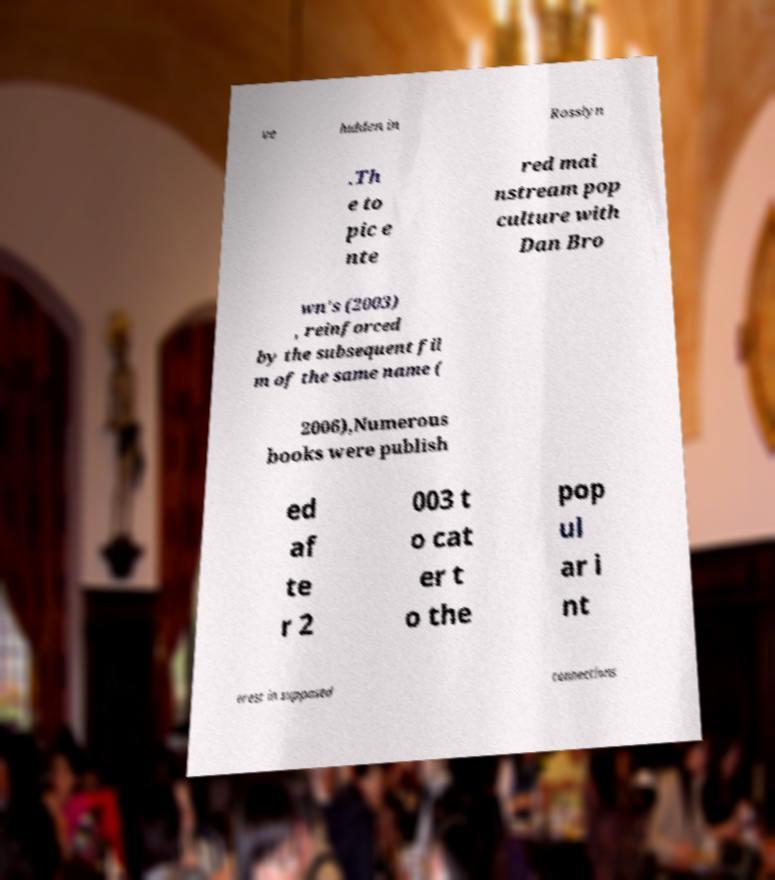I need the written content from this picture converted into text. Can you do that? ve hidden in Rosslyn .Th e to pic e nte red mai nstream pop culture with Dan Bro wn's (2003) , reinforced by the subsequent fil m of the same name ( 2006),Numerous books were publish ed af te r 2 003 t o cat er t o the pop ul ar i nt erest in supposed connections 